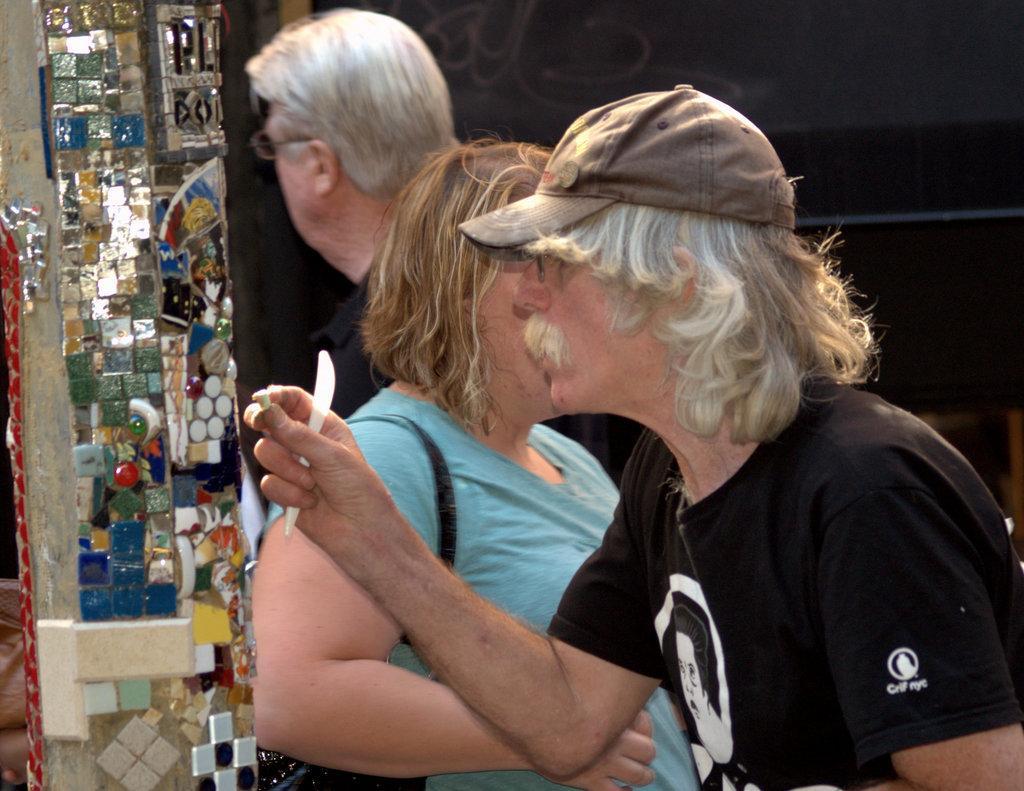Please provide a concise description of this image. In this picture I can see few people standing and I can see a man holding something in his hand. I can see few stones on the pillar and a dark background. 